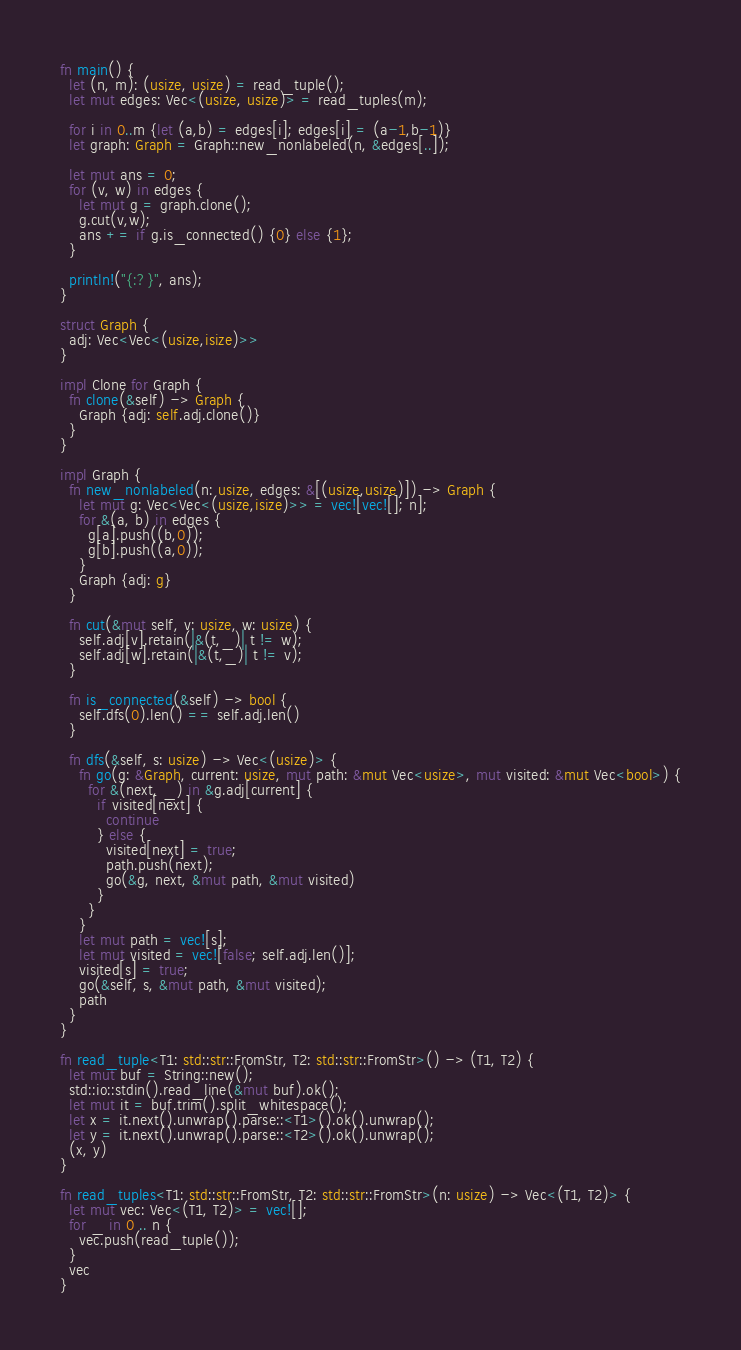Convert code to text. <code><loc_0><loc_0><loc_500><loc_500><_Rust_>fn main() {
  let (n, m): (usize, usize) = read_tuple();
  let mut edges: Vec<(usize, usize)> = read_tuples(m);
  
  for i in 0..m {let (a,b) = edges[i]; edges[i] = (a-1,b-1)}
  let graph: Graph = Graph::new_nonlabeled(n, &edges[..]);
  
  let mut ans = 0;
  for (v, w) in edges {
    let mut g = graph.clone();
    g.cut(v,w);
    ans += if g.is_connected() {0} else {1};
  }
  
  println!("{:?}", ans);
}

struct Graph {
  adj: Vec<Vec<(usize,isize)>>
}

impl Clone for Graph {
  fn clone(&self) -> Graph {
    Graph {adj: self.adj.clone()}
  }
}

impl Graph {
  fn new_nonlabeled(n: usize, edges: &[(usize,usize)]) -> Graph {
    let mut g: Vec<Vec<(usize,isize)>> = vec![vec![]; n];
    for &(a, b) in edges {
      g[a].push((b,0));
      g[b].push((a,0));
    }
    Graph {adj: g}
  }
  
  fn cut(&mut self, v: usize, w: usize) {
    self.adj[v].retain(|&(t,_)| t != w);
    self.adj[w].retain(|&(t,_)| t != v);
  }
  
  fn is_connected(&self) -> bool {
    self.dfs(0).len() == self.adj.len()
  }
  
  fn dfs(&self, s: usize) -> Vec<(usize)> {
    fn go(g: &Graph, current: usize, mut path: &mut Vec<usize>, mut visited: &mut Vec<bool>) {
      for &(next, _) in &g.adj[current] {
        if visited[next] {
          continue
        } else {
          visited[next] = true;
          path.push(next);
          go(&g, next, &mut path, &mut visited)
        }
      }
    }
    let mut path = vec![s];
    let mut visited = vec![false; self.adj.len()];
    visited[s] = true;
    go(&self, s, &mut path, &mut visited);
    path
  }
}

fn read_tuple<T1: std::str::FromStr, T2: std::str::FromStr>() -> (T1, T2) {
  let mut buf = String::new();
  std::io::stdin().read_line(&mut buf).ok();
  let mut it = buf.trim().split_whitespace();
  let x = it.next().unwrap().parse::<T1>().ok().unwrap();
  let y = it.next().unwrap().parse::<T2>().ok().unwrap();
  (x, y)
}

fn read_tuples<T1: std::str::FromStr, T2: std::str::FromStr>(n: usize) -> Vec<(T1, T2)> {
  let mut vec: Vec<(T1, T2)> = vec![];
  for _ in 0 .. n {
    vec.push(read_tuple());
  }
  vec
}
</code> 